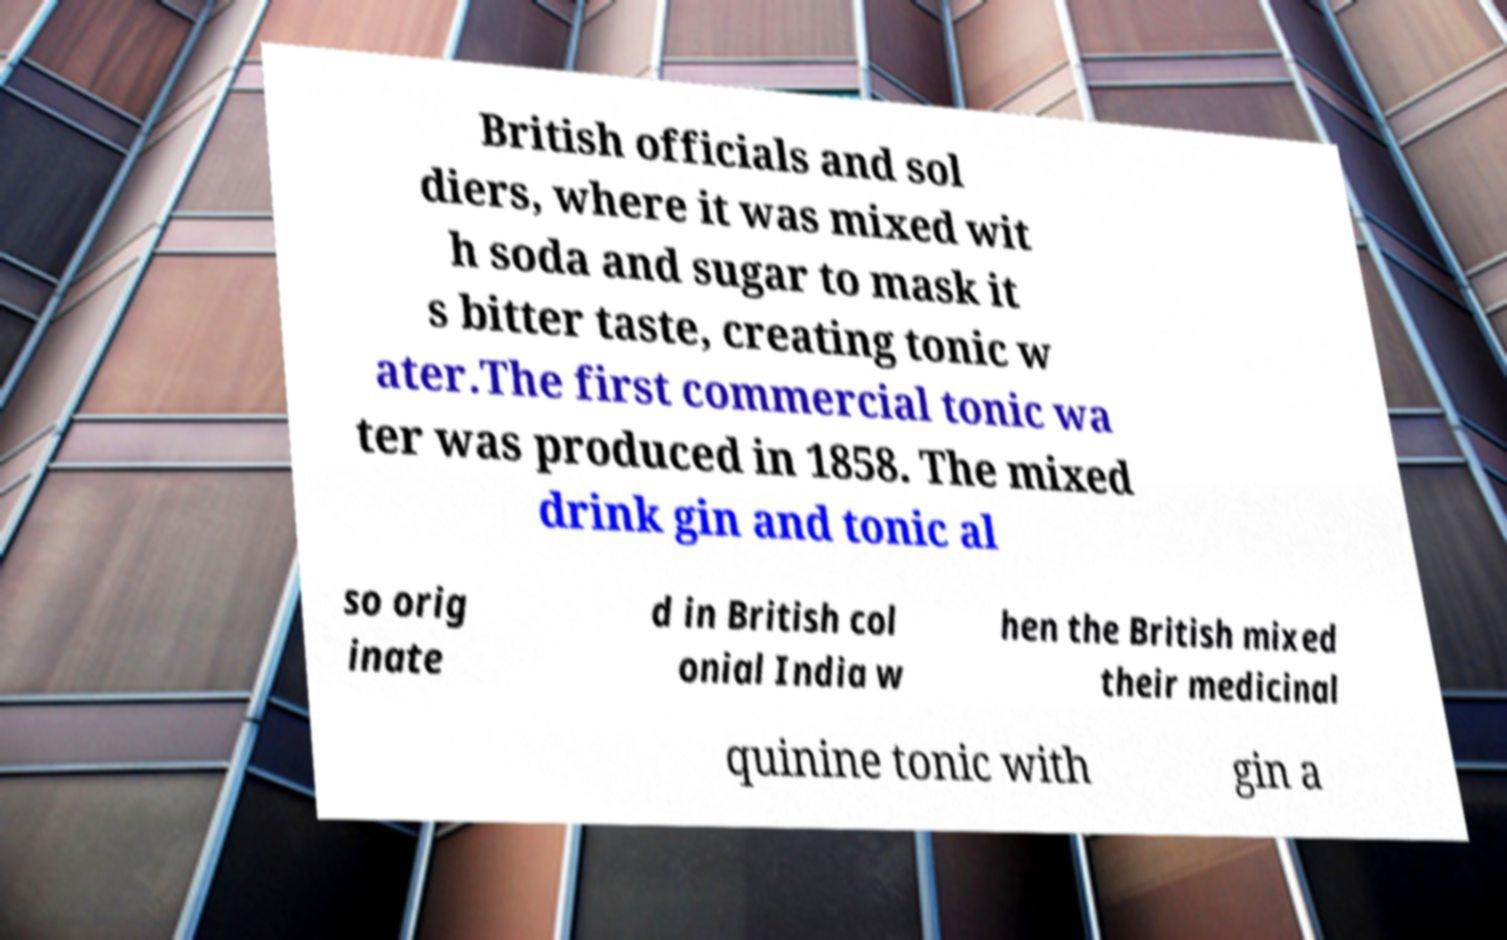For documentation purposes, I need the text within this image transcribed. Could you provide that? British officials and sol diers, where it was mixed wit h soda and sugar to mask it s bitter taste, creating tonic w ater.The first commercial tonic wa ter was produced in 1858. The mixed drink gin and tonic al so orig inate d in British col onial India w hen the British mixed their medicinal quinine tonic with gin a 